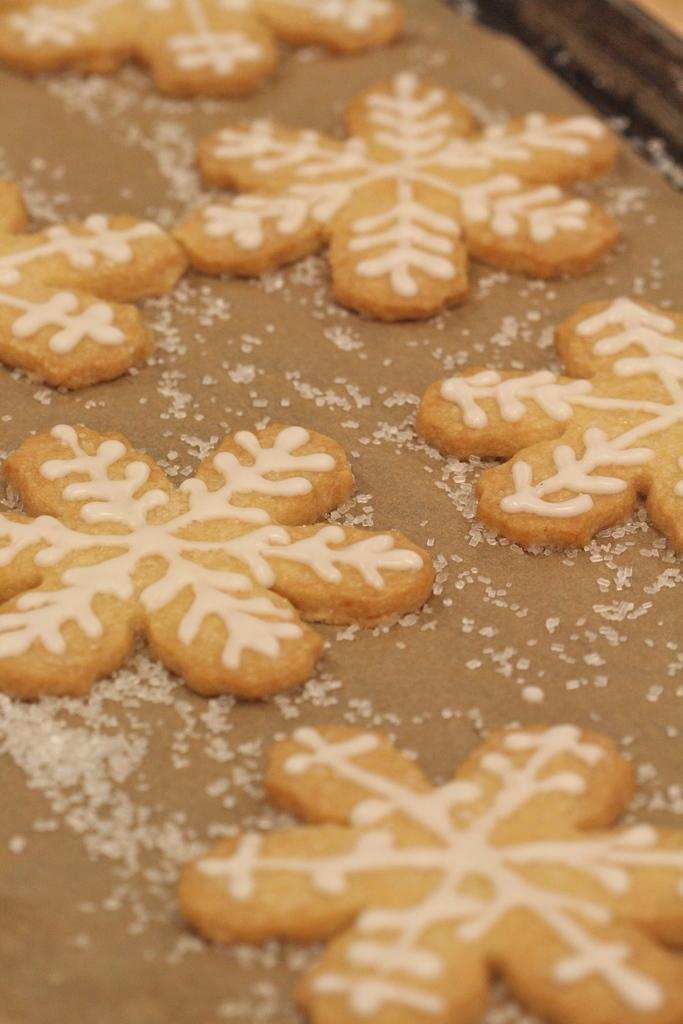What types of items can be seen on the surface in the image? There are food items and crystal objects on the surface in the image. Can you describe the food items in more detail? Unfortunately, the specific food items cannot be identified from the image. What can be said about the crystal objects? The crystal objects are visible on the surface in the image. What is located in the top right corner of the image? There is an unspecified object in the top right corner of the image. How many passengers are visible in the image? There are no passengers present in the image. What type of group is shown interacting with the crystal objects in the image? There is no group present in the image; only the food items, crystal objects, and unspecified object can be seen. 